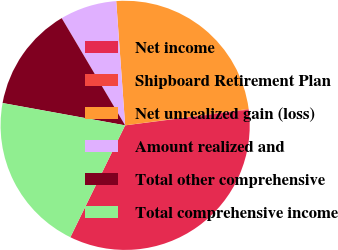Convert chart. <chart><loc_0><loc_0><loc_500><loc_500><pie_chart><fcel>Net income<fcel>Shipboard Retirement Plan<fcel>Net unrealized gain (loss)<fcel>Amount realized and<fcel>Total other comprehensive<fcel>Total comprehensive income<nl><fcel>34.26%<fcel>0.09%<fcel>24.04%<fcel>7.36%<fcel>13.63%<fcel>20.62%<nl></chart> 